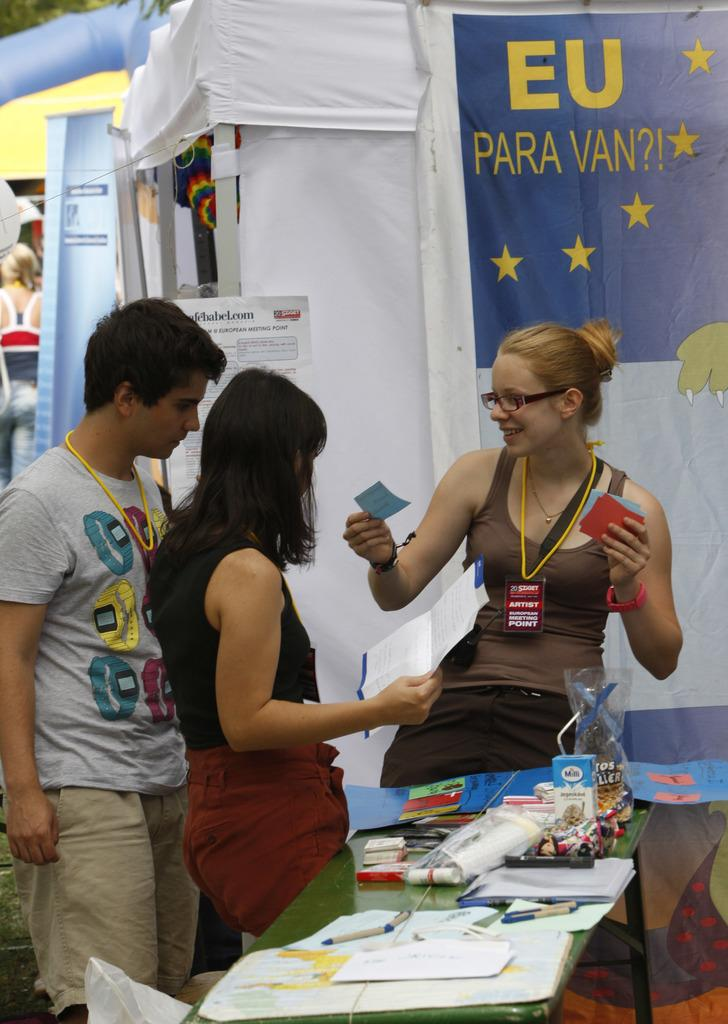<image>
Present a compact description of the photo's key features. Woman giving out paper under a EU Para Van?1 flag 